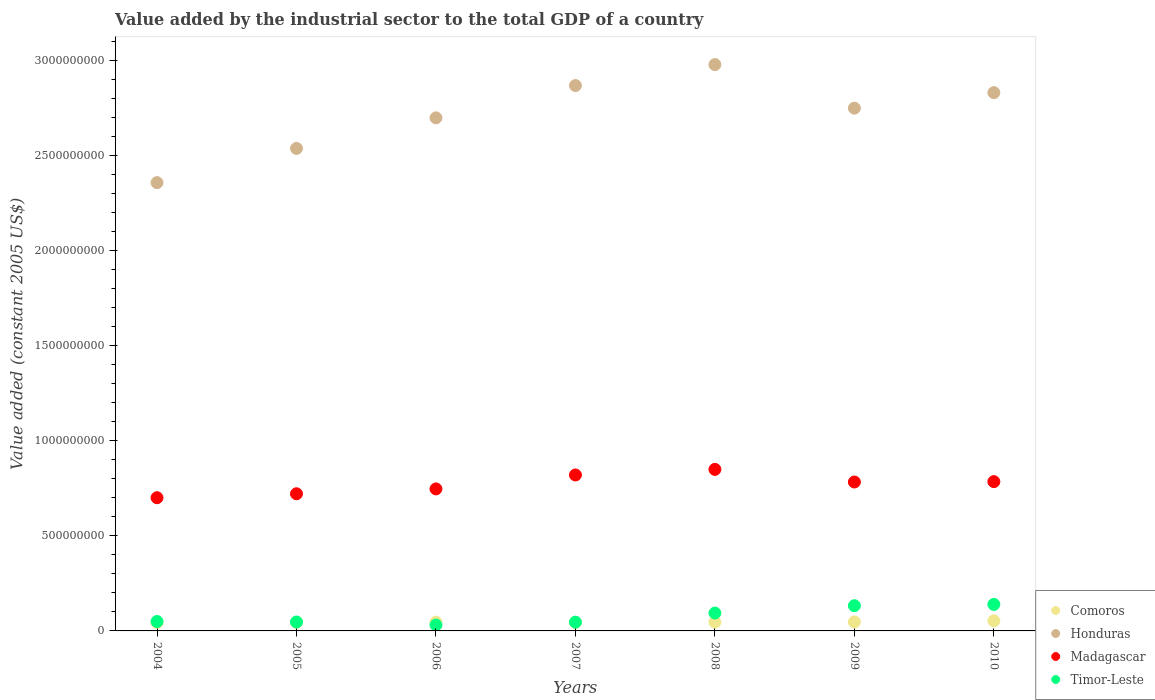What is the value added by the industrial sector in Honduras in 2009?
Provide a succinct answer. 2.75e+09. Across all years, what is the maximum value added by the industrial sector in Timor-Leste?
Ensure brevity in your answer.  1.39e+08. Across all years, what is the minimum value added by the industrial sector in Comoros?
Offer a terse response. 4.38e+07. In which year was the value added by the industrial sector in Madagascar maximum?
Make the answer very short. 2008. In which year was the value added by the industrial sector in Honduras minimum?
Offer a terse response. 2004. What is the total value added by the industrial sector in Timor-Leste in the graph?
Give a very brief answer. 5.40e+08. What is the difference between the value added by the industrial sector in Madagascar in 2005 and that in 2009?
Make the answer very short. -6.19e+07. What is the difference between the value added by the industrial sector in Comoros in 2005 and the value added by the industrial sector in Timor-Leste in 2009?
Provide a short and direct response. -8.77e+07. What is the average value added by the industrial sector in Comoros per year?
Offer a terse response. 4.65e+07. In the year 2006, what is the difference between the value added by the industrial sector in Comoros and value added by the industrial sector in Honduras?
Keep it short and to the point. -2.65e+09. In how many years, is the value added by the industrial sector in Honduras greater than 1600000000 US$?
Your answer should be very brief. 7. What is the ratio of the value added by the industrial sector in Honduras in 2004 to that in 2007?
Your answer should be compact. 0.82. Is the difference between the value added by the industrial sector in Comoros in 2005 and 2010 greater than the difference between the value added by the industrial sector in Honduras in 2005 and 2010?
Your answer should be very brief. Yes. What is the difference between the highest and the second highest value added by the industrial sector in Honduras?
Provide a short and direct response. 1.10e+08. What is the difference between the highest and the lowest value added by the industrial sector in Timor-Leste?
Provide a succinct answer. 1.08e+08. In how many years, is the value added by the industrial sector in Honduras greater than the average value added by the industrial sector in Honduras taken over all years?
Provide a succinct answer. 4. Is the sum of the value added by the industrial sector in Honduras in 2005 and 2006 greater than the maximum value added by the industrial sector in Madagascar across all years?
Provide a short and direct response. Yes. Is it the case that in every year, the sum of the value added by the industrial sector in Honduras and value added by the industrial sector in Comoros  is greater than the sum of value added by the industrial sector in Madagascar and value added by the industrial sector in Timor-Leste?
Your answer should be very brief. No. Does the value added by the industrial sector in Honduras monotonically increase over the years?
Keep it short and to the point. No. What is the difference between two consecutive major ticks on the Y-axis?
Offer a terse response. 5.00e+08. Are the values on the major ticks of Y-axis written in scientific E-notation?
Offer a very short reply. No. Does the graph contain any zero values?
Make the answer very short. No. What is the title of the graph?
Make the answer very short. Value added by the industrial sector to the total GDP of a country. Does "France" appear as one of the legend labels in the graph?
Your response must be concise. No. What is the label or title of the X-axis?
Your answer should be compact. Years. What is the label or title of the Y-axis?
Your response must be concise. Value added (constant 2005 US$). What is the Value added (constant 2005 US$) of Comoros in 2004?
Make the answer very short. 4.38e+07. What is the Value added (constant 2005 US$) of Honduras in 2004?
Your answer should be compact. 2.36e+09. What is the Value added (constant 2005 US$) in Madagascar in 2004?
Ensure brevity in your answer.  7.01e+08. What is the Value added (constant 2005 US$) of Timor-Leste in 2004?
Your answer should be very brief. 4.95e+07. What is the Value added (constant 2005 US$) of Comoros in 2005?
Give a very brief answer. 4.49e+07. What is the Value added (constant 2005 US$) of Honduras in 2005?
Provide a short and direct response. 2.54e+09. What is the Value added (constant 2005 US$) of Madagascar in 2005?
Your answer should be compact. 7.21e+08. What is the Value added (constant 2005 US$) of Timor-Leste in 2005?
Keep it short and to the point. 4.70e+07. What is the Value added (constant 2005 US$) of Comoros in 2006?
Provide a succinct answer. 4.63e+07. What is the Value added (constant 2005 US$) of Honduras in 2006?
Your response must be concise. 2.70e+09. What is the Value added (constant 2005 US$) in Madagascar in 2006?
Ensure brevity in your answer.  7.47e+08. What is the Value added (constant 2005 US$) in Timor-Leste in 2006?
Your response must be concise. 3.11e+07. What is the Value added (constant 2005 US$) in Comoros in 2007?
Provide a succinct answer. 4.42e+07. What is the Value added (constant 2005 US$) in Honduras in 2007?
Offer a very short reply. 2.87e+09. What is the Value added (constant 2005 US$) of Madagascar in 2007?
Your answer should be compact. 8.20e+08. What is the Value added (constant 2005 US$) of Timor-Leste in 2007?
Provide a succinct answer. 4.62e+07. What is the Value added (constant 2005 US$) in Comoros in 2008?
Provide a short and direct response. 4.62e+07. What is the Value added (constant 2005 US$) in Honduras in 2008?
Your answer should be very brief. 2.98e+09. What is the Value added (constant 2005 US$) in Madagascar in 2008?
Your response must be concise. 8.50e+08. What is the Value added (constant 2005 US$) in Timor-Leste in 2008?
Your answer should be very brief. 9.40e+07. What is the Value added (constant 2005 US$) in Comoros in 2009?
Give a very brief answer. 4.71e+07. What is the Value added (constant 2005 US$) of Honduras in 2009?
Offer a terse response. 2.75e+09. What is the Value added (constant 2005 US$) of Madagascar in 2009?
Your response must be concise. 7.83e+08. What is the Value added (constant 2005 US$) of Timor-Leste in 2009?
Provide a succinct answer. 1.33e+08. What is the Value added (constant 2005 US$) in Comoros in 2010?
Provide a short and direct response. 5.31e+07. What is the Value added (constant 2005 US$) in Honduras in 2010?
Offer a very short reply. 2.83e+09. What is the Value added (constant 2005 US$) in Madagascar in 2010?
Provide a short and direct response. 7.85e+08. What is the Value added (constant 2005 US$) in Timor-Leste in 2010?
Offer a terse response. 1.39e+08. Across all years, what is the maximum Value added (constant 2005 US$) of Comoros?
Ensure brevity in your answer.  5.31e+07. Across all years, what is the maximum Value added (constant 2005 US$) in Honduras?
Provide a short and direct response. 2.98e+09. Across all years, what is the maximum Value added (constant 2005 US$) of Madagascar?
Make the answer very short. 8.50e+08. Across all years, what is the maximum Value added (constant 2005 US$) in Timor-Leste?
Your response must be concise. 1.39e+08. Across all years, what is the minimum Value added (constant 2005 US$) in Comoros?
Ensure brevity in your answer.  4.38e+07. Across all years, what is the minimum Value added (constant 2005 US$) of Honduras?
Offer a terse response. 2.36e+09. Across all years, what is the minimum Value added (constant 2005 US$) in Madagascar?
Make the answer very short. 7.01e+08. Across all years, what is the minimum Value added (constant 2005 US$) in Timor-Leste?
Make the answer very short. 3.11e+07. What is the total Value added (constant 2005 US$) in Comoros in the graph?
Make the answer very short. 3.26e+08. What is the total Value added (constant 2005 US$) in Honduras in the graph?
Ensure brevity in your answer.  1.90e+1. What is the total Value added (constant 2005 US$) in Madagascar in the graph?
Your answer should be compact. 5.41e+09. What is the total Value added (constant 2005 US$) of Timor-Leste in the graph?
Your answer should be very brief. 5.40e+08. What is the difference between the Value added (constant 2005 US$) of Comoros in 2004 and that in 2005?
Keep it short and to the point. -1.10e+06. What is the difference between the Value added (constant 2005 US$) in Honduras in 2004 and that in 2005?
Your answer should be very brief. -1.80e+08. What is the difference between the Value added (constant 2005 US$) of Madagascar in 2004 and that in 2005?
Keep it short and to the point. -2.08e+07. What is the difference between the Value added (constant 2005 US$) in Timor-Leste in 2004 and that in 2005?
Provide a short and direct response. 2.52e+06. What is the difference between the Value added (constant 2005 US$) of Comoros in 2004 and that in 2006?
Your response must be concise. -2.42e+06. What is the difference between the Value added (constant 2005 US$) in Honduras in 2004 and that in 2006?
Keep it short and to the point. -3.41e+08. What is the difference between the Value added (constant 2005 US$) in Madagascar in 2004 and that in 2006?
Your response must be concise. -4.63e+07. What is the difference between the Value added (constant 2005 US$) in Timor-Leste in 2004 and that in 2006?
Your answer should be very brief. 1.85e+07. What is the difference between the Value added (constant 2005 US$) in Comoros in 2004 and that in 2007?
Offer a very short reply. -4.05e+05. What is the difference between the Value added (constant 2005 US$) in Honduras in 2004 and that in 2007?
Your answer should be very brief. -5.11e+08. What is the difference between the Value added (constant 2005 US$) in Madagascar in 2004 and that in 2007?
Your answer should be very brief. -1.20e+08. What is the difference between the Value added (constant 2005 US$) of Timor-Leste in 2004 and that in 2007?
Give a very brief answer. 3.36e+06. What is the difference between the Value added (constant 2005 US$) in Comoros in 2004 and that in 2008?
Your response must be concise. -2.34e+06. What is the difference between the Value added (constant 2005 US$) in Honduras in 2004 and that in 2008?
Your answer should be very brief. -6.21e+08. What is the difference between the Value added (constant 2005 US$) in Madagascar in 2004 and that in 2008?
Ensure brevity in your answer.  -1.49e+08. What is the difference between the Value added (constant 2005 US$) in Timor-Leste in 2004 and that in 2008?
Give a very brief answer. -4.45e+07. What is the difference between the Value added (constant 2005 US$) of Comoros in 2004 and that in 2009?
Your answer should be very brief. -3.30e+06. What is the difference between the Value added (constant 2005 US$) in Honduras in 2004 and that in 2009?
Provide a succinct answer. -3.92e+08. What is the difference between the Value added (constant 2005 US$) in Madagascar in 2004 and that in 2009?
Your response must be concise. -8.26e+07. What is the difference between the Value added (constant 2005 US$) in Timor-Leste in 2004 and that in 2009?
Your answer should be very brief. -8.31e+07. What is the difference between the Value added (constant 2005 US$) of Comoros in 2004 and that in 2010?
Offer a terse response. -9.29e+06. What is the difference between the Value added (constant 2005 US$) in Honduras in 2004 and that in 2010?
Provide a succinct answer. -4.73e+08. What is the difference between the Value added (constant 2005 US$) of Madagascar in 2004 and that in 2010?
Make the answer very short. -8.46e+07. What is the difference between the Value added (constant 2005 US$) of Timor-Leste in 2004 and that in 2010?
Your response must be concise. -8.98e+07. What is the difference between the Value added (constant 2005 US$) in Comoros in 2005 and that in 2006?
Ensure brevity in your answer.  -1.32e+06. What is the difference between the Value added (constant 2005 US$) in Honduras in 2005 and that in 2006?
Offer a very short reply. -1.61e+08. What is the difference between the Value added (constant 2005 US$) of Madagascar in 2005 and that in 2006?
Give a very brief answer. -2.55e+07. What is the difference between the Value added (constant 2005 US$) of Timor-Leste in 2005 and that in 2006?
Give a very brief answer. 1.59e+07. What is the difference between the Value added (constant 2005 US$) of Comoros in 2005 and that in 2007?
Keep it short and to the point. 6.92e+05. What is the difference between the Value added (constant 2005 US$) of Honduras in 2005 and that in 2007?
Your answer should be very brief. -3.31e+08. What is the difference between the Value added (constant 2005 US$) of Madagascar in 2005 and that in 2007?
Keep it short and to the point. -9.88e+07. What is the difference between the Value added (constant 2005 US$) in Timor-Leste in 2005 and that in 2007?
Ensure brevity in your answer.  8.39e+05. What is the difference between the Value added (constant 2005 US$) in Comoros in 2005 and that in 2008?
Provide a succinct answer. -1.24e+06. What is the difference between the Value added (constant 2005 US$) of Honduras in 2005 and that in 2008?
Your response must be concise. -4.41e+08. What is the difference between the Value added (constant 2005 US$) in Madagascar in 2005 and that in 2008?
Provide a short and direct response. -1.28e+08. What is the difference between the Value added (constant 2005 US$) of Timor-Leste in 2005 and that in 2008?
Keep it short and to the point. -4.70e+07. What is the difference between the Value added (constant 2005 US$) of Comoros in 2005 and that in 2009?
Offer a terse response. -2.20e+06. What is the difference between the Value added (constant 2005 US$) of Honduras in 2005 and that in 2009?
Your answer should be very brief. -2.12e+08. What is the difference between the Value added (constant 2005 US$) of Madagascar in 2005 and that in 2009?
Give a very brief answer. -6.19e+07. What is the difference between the Value added (constant 2005 US$) of Timor-Leste in 2005 and that in 2009?
Offer a very short reply. -8.56e+07. What is the difference between the Value added (constant 2005 US$) in Comoros in 2005 and that in 2010?
Offer a very short reply. -8.19e+06. What is the difference between the Value added (constant 2005 US$) in Honduras in 2005 and that in 2010?
Your answer should be very brief. -2.93e+08. What is the difference between the Value added (constant 2005 US$) in Madagascar in 2005 and that in 2010?
Your response must be concise. -6.38e+07. What is the difference between the Value added (constant 2005 US$) in Timor-Leste in 2005 and that in 2010?
Your answer should be compact. -9.23e+07. What is the difference between the Value added (constant 2005 US$) in Comoros in 2006 and that in 2007?
Your answer should be very brief. 2.01e+06. What is the difference between the Value added (constant 2005 US$) in Honduras in 2006 and that in 2007?
Offer a very short reply. -1.70e+08. What is the difference between the Value added (constant 2005 US$) in Madagascar in 2006 and that in 2007?
Your response must be concise. -7.33e+07. What is the difference between the Value added (constant 2005 US$) of Timor-Leste in 2006 and that in 2007?
Give a very brief answer. -1.51e+07. What is the difference between the Value added (constant 2005 US$) of Comoros in 2006 and that in 2008?
Keep it short and to the point. 7.71e+04. What is the difference between the Value added (constant 2005 US$) of Honduras in 2006 and that in 2008?
Your answer should be very brief. -2.80e+08. What is the difference between the Value added (constant 2005 US$) of Madagascar in 2006 and that in 2008?
Ensure brevity in your answer.  -1.03e+08. What is the difference between the Value added (constant 2005 US$) in Timor-Leste in 2006 and that in 2008?
Your response must be concise. -6.29e+07. What is the difference between the Value added (constant 2005 US$) in Comoros in 2006 and that in 2009?
Your response must be concise. -8.80e+05. What is the difference between the Value added (constant 2005 US$) in Honduras in 2006 and that in 2009?
Your answer should be very brief. -5.09e+07. What is the difference between the Value added (constant 2005 US$) of Madagascar in 2006 and that in 2009?
Ensure brevity in your answer.  -3.64e+07. What is the difference between the Value added (constant 2005 US$) in Timor-Leste in 2006 and that in 2009?
Offer a very short reply. -1.02e+08. What is the difference between the Value added (constant 2005 US$) of Comoros in 2006 and that in 2010?
Provide a succinct answer. -6.87e+06. What is the difference between the Value added (constant 2005 US$) in Honduras in 2006 and that in 2010?
Your answer should be very brief. -1.33e+08. What is the difference between the Value added (constant 2005 US$) of Madagascar in 2006 and that in 2010?
Make the answer very short. -3.83e+07. What is the difference between the Value added (constant 2005 US$) of Timor-Leste in 2006 and that in 2010?
Keep it short and to the point. -1.08e+08. What is the difference between the Value added (constant 2005 US$) of Comoros in 2007 and that in 2008?
Your answer should be compact. -1.94e+06. What is the difference between the Value added (constant 2005 US$) in Honduras in 2007 and that in 2008?
Provide a short and direct response. -1.10e+08. What is the difference between the Value added (constant 2005 US$) in Madagascar in 2007 and that in 2008?
Offer a very short reply. -2.93e+07. What is the difference between the Value added (constant 2005 US$) in Timor-Leste in 2007 and that in 2008?
Your answer should be very brief. -4.78e+07. What is the difference between the Value added (constant 2005 US$) in Comoros in 2007 and that in 2009?
Your answer should be very brief. -2.89e+06. What is the difference between the Value added (constant 2005 US$) of Honduras in 2007 and that in 2009?
Keep it short and to the point. 1.19e+08. What is the difference between the Value added (constant 2005 US$) of Madagascar in 2007 and that in 2009?
Your answer should be very brief. 3.70e+07. What is the difference between the Value added (constant 2005 US$) in Timor-Leste in 2007 and that in 2009?
Your answer should be very brief. -8.64e+07. What is the difference between the Value added (constant 2005 US$) in Comoros in 2007 and that in 2010?
Give a very brief answer. -8.88e+06. What is the difference between the Value added (constant 2005 US$) of Honduras in 2007 and that in 2010?
Ensure brevity in your answer.  3.72e+07. What is the difference between the Value added (constant 2005 US$) in Madagascar in 2007 and that in 2010?
Your response must be concise. 3.50e+07. What is the difference between the Value added (constant 2005 US$) of Timor-Leste in 2007 and that in 2010?
Make the answer very short. -9.32e+07. What is the difference between the Value added (constant 2005 US$) in Comoros in 2008 and that in 2009?
Your answer should be compact. -9.57e+05. What is the difference between the Value added (constant 2005 US$) of Honduras in 2008 and that in 2009?
Your answer should be very brief. 2.29e+08. What is the difference between the Value added (constant 2005 US$) of Madagascar in 2008 and that in 2009?
Offer a very short reply. 6.63e+07. What is the difference between the Value added (constant 2005 US$) in Timor-Leste in 2008 and that in 2009?
Your response must be concise. -3.86e+07. What is the difference between the Value added (constant 2005 US$) of Comoros in 2008 and that in 2010?
Give a very brief answer. -6.95e+06. What is the difference between the Value added (constant 2005 US$) of Honduras in 2008 and that in 2010?
Provide a succinct answer. 1.47e+08. What is the difference between the Value added (constant 2005 US$) of Madagascar in 2008 and that in 2010?
Ensure brevity in your answer.  6.43e+07. What is the difference between the Value added (constant 2005 US$) in Timor-Leste in 2008 and that in 2010?
Your answer should be very brief. -4.53e+07. What is the difference between the Value added (constant 2005 US$) of Comoros in 2009 and that in 2010?
Keep it short and to the point. -5.99e+06. What is the difference between the Value added (constant 2005 US$) in Honduras in 2009 and that in 2010?
Provide a short and direct response. -8.17e+07. What is the difference between the Value added (constant 2005 US$) of Madagascar in 2009 and that in 2010?
Provide a short and direct response. -1.94e+06. What is the difference between the Value added (constant 2005 US$) of Timor-Leste in 2009 and that in 2010?
Give a very brief answer. -6.71e+06. What is the difference between the Value added (constant 2005 US$) in Comoros in 2004 and the Value added (constant 2005 US$) in Honduras in 2005?
Make the answer very short. -2.49e+09. What is the difference between the Value added (constant 2005 US$) of Comoros in 2004 and the Value added (constant 2005 US$) of Madagascar in 2005?
Your answer should be very brief. -6.78e+08. What is the difference between the Value added (constant 2005 US$) in Comoros in 2004 and the Value added (constant 2005 US$) in Timor-Leste in 2005?
Offer a very short reply. -3.16e+06. What is the difference between the Value added (constant 2005 US$) in Honduras in 2004 and the Value added (constant 2005 US$) in Madagascar in 2005?
Offer a terse response. 1.64e+09. What is the difference between the Value added (constant 2005 US$) of Honduras in 2004 and the Value added (constant 2005 US$) of Timor-Leste in 2005?
Provide a succinct answer. 2.31e+09. What is the difference between the Value added (constant 2005 US$) in Madagascar in 2004 and the Value added (constant 2005 US$) in Timor-Leste in 2005?
Provide a succinct answer. 6.54e+08. What is the difference between the Value added (constant 2005 US$) in Comoros in 2004 and the Value added (constant 2005 US$) in Honduras in 2006?
Your answer should be very brief. -2.65e+09. What is the difference between the Value added (constant 2005 US$) of Comoros in 2004 and the Value added (constant 2005 US$) of Madagascar in 2006?
Offer a very short reply. -7.03e+08. What is the difference between the Value added (constant 2005 US$) in Comoros in 2004 and the Value added (constant 2005 US$) in Timor-Leste in 2006?
Give a very brief answer. 1.28e+07. What is the difference between the Value added (constant 2005 US$) of Honduras in 2004 and the Value added (constant 2005 US$) of Madagascar in 2006?
Keep it short and to the point. 1.61e+09. What is the difference between the Value added (constant 2005 US$) of Honduras in 2004 and the Value added (constant 2005 US$) of Timor-Leste in 2006?
Your answer should be compact. 2.33e+09. What is the difference between the Value added (constant 2005 US$) of Madagascar in 2004 and the Value added (constant 2005 US$) of Timor-Leste in 2006?
Make the answer very short. 6.70e+08. What is the difference between the Value added (constant 2005 US$) in Comoros in 2004 and the Value added (constant 2005 US$) in Honduras in 2007?
Offer a terse response. -2.82e+09. What is the difference between the Value added (constant 2005 US$) in Comoros in 2004 and the Value added (constant 2005 US$) in Madagascar in 2007?
Provide a short and direct response. -7.76e+08. What is the difference between the Value added (constant 2005 US$) of Comoros in 2004 and the Value added (constant 2005 US$) of Timor-Leste in 2007?
Offer a very short reply. -2.32e+06. What is the difference between the Value added (constant 2005 US$) in Honduras in 2004 and the Value added (constant 2005 US$) in Madagascar in 2007?
Your answer should be compact. 1.54e+09. What is the difference between the Value added (constant 2005 US$) in Honduras in 2004 and the Value added (constant 2005 US$) in Timor-Leste in 2007?
Your answer should be very brief. 2.31e+09. What is the difference between the Value added (constant 2005 US$) in Madagascar in 2004 and the Value added (constant 2005 US$) in Timor-Leste in 2007?
Offer a terse response. 6.55e+08. What is the difference between the Value added (constant 2005 US$) in Comoros in 2004 and the Value added (constant 2005 US$) in Honduras in 2008?
Make the answer very short. -2.93e+09. What is the difference between the Value added (constant 2005 US$) in Comoros in 2004 and the Value added (constant 2005 US$) in Madagascar in 2008?
Offer a very short reply. -8.06e+08. What is the difference between the Value added (constant 2005 US$) of Comoros in 2004 and the Value added (constant 2005 US$) of Timor-Leste in 2008?
Your answer should be very brief. -5.02e+07. What is the difference between the Value added (constant 2005 US$) in Honduras in 2004 and the Value added (constant 2005 US$) in Madagascar in 2008?
Your answer should be compact. 1.51e+09. What is the difference between the Value added (constant 2005 US$) in Honduras in 2004 and the Value added (constant 2005 US$) in Timor-Leste in 2008?
Ensure brevity in your answer.  2.26e+09. What is the difference between the Value added (constant 2005 US$) in Madagascar in 2004 and the Value added (constant 2005 US$) in Timor-Leste in 2008?
Keep it short and to the point. 6.07e+08. What is the difference between the Value added (constant 2005 US$) in Comoros in 2004 and the Value added (constant 2005 US$) in Honduras in 2009?
Give a very brief answer. -2.71e+09. What is the difference between the Value added (constant 2005 US$) of Comoros in 2004 and the Value added (constant 2005 US$) of Madagascar in 2009?
Keep it short and to the point. -7.39e+08. What is the difference between the Value added (constant 2005 US$) in Comoros in 2004 and the Value added (constant 2005 US$) in Timor-Leste in 2009?
Your answer should be compact. -8.88e+07. What is the difference between the Value added (constant 2005 US$) of Honduras in 2004 and the Value added (constant 2005 US$) of Madagascar in 2009?
Keep it short and to the point. 1.57e+09. What is the difference between the Value added (constant 2005 US$) in Honduras in 2004 and the Value added (constant 2005 US$) in Timor-Leste in 2009?
Give a very brief answer. 2.23e+09. What is the difference between the Value added (constant 2005 US$) in Madagascar in 2004 and the Value added (constant 2005 US$) in Timor-Leste in 2009?
Offer a very short reply. 5.68e+08. What is the difference between the Value added (constant 2005 US$) in Comoros in 2004 and the Value added (constant 2005 US$) in Honduras in 2010?
Ensure brevity in your answer.  -2.79e+09. What is the difference between the Value added (constant 2005 US$) in Comoros in 2004 and the Value added (constant 2005 US$) in Madagascar in 2010?
Give a very brief answer. -7.41e+08. What is the difference between the Value added (constant 2005 US$) in Comoros in 2004 and the Value added (constant 2005 US$) in Timor-Leste in 2010?
Offer a very short reply. -9.55e+07. What is the difference between the Value added (constant 2005 US$) of Honduras in 2004 and the Value added (constant 2005 US$) of Madagascar in 2010?
Your answer should be very brief. 1.57e+09. What is the difference between the Value added (constant 2005 US$) in Honduras in 2004 and the Value added (constant 2005 US$) in Timor-Leste in 2010?
Ensure brevity in your answer.  2.22e+09. What is the difference between the Value added (constant 2005 US$) in Madagascar in 2004 and the Value added (constant 2005 US$) in Timor-Leste in 2010?
Provide a succinct answer. 5.61e+08. What is the difference between the Value added (constant 2005 US$) of Comoros in 2005 and the Value added (constant 2005 US$) of Honduras in 2006?
Your response must be concise. -2.65e+09. What is the difference between the Value added (constant 2005 US$) in Comoros in 2005 and the Value added (constant 2005 US$) in Madagascar in 2006?
Make the answer very short. -7.02e+08. What is the difference between the Value added (constant 2005 US$) of Comoros in 2005 and the Value added (constant 2005 US$) of Timor-Leste in 2006?
Provide a short and direct response. 1.39e+07. What is the difference between the Value added (constant 2005 US$) in Honduras in 2005 and the Value added (constant 2005 US$) in Madagascar in 2006?
Your answer should be compact. 1.79e+09. What is the difference between the Value added (constant 2005 US$) of Honduras in 2005 and the Value added (constant 2005 US$) of Timor-Leste in 2006?
Give a very brief answer. 2.51e+09. What is the difference between the Value added (constant 2005 US$) in Madagascar in 2005 and the Value added (constant 2005 US$) in Timor-Leste in 2006?
Offer a very short reply. 6.90e+08. What is the difference between the Value added (constant 2005 US$) in Comoros in 2005 and the Value added (constant 2005 US$) in Honduras in 2007?
Your response must be concise. -2.82e+09. What is the difference between the Value added (constant 2005 US$) of Comoros in 2005 and the Value added (constant 2005 US$) of Madagascar in 2007?
Ensure brevity in your answer.  -7.75e+08. What is the difference between the Value added (constant 2005 US$) of Comoros in 2005 and the Value added (constant 2005 US$) of Timor-Leste in 2007?
Offer a terse response. -1.23e+06. What is the difference between the Value added (constant 2005 US$) in Honduras in 2005 and the Value added (constant 2005 US$) in Madagascar in 2007?
Offer a very short reply. 1.72e+09. What is the difference between the Value added (constant 2005 US$) of Honduras in 2005 and the Value added (constant 2005 US$) of Timor-Leste in 2007?
Ensure brevity in your answer.  2.49e+09. What is the difference between the Value added (constant 2005 US$) of Madagascar in 2005 and the Value added (constant 2005 US$) of Timor-Leste in 2007?
Keep it short and to the point. 6.75e+08. What is the difference between the Value added (constant 2005 US$) of Comoros in 2005 and the Value added (constant 2005 US$) of Honduras in 2008?
Keep it short and to the point. -2.93e+09. What is the difference between the Value added (constant 2005 US$) in Comoros in 2005 and the Value added (constant 2005 US$) in Madagascar in 2008?
Your answer should be very brief. -8.05e+08. What is the difference between the Value added (constant 2005 US$) in Comoros in 2005 and the Value added (constant 2005 US$) in Timor-Leste in 2008?
Give a very brief answer. -4.91e+07. What is the difference between the Value added (constant 2005 US$) of Honduras in 2005 and the Value added (constant 2005 US$) of Madagascar in 2008?
Make the answer very short. 1.69e+09. What is the difference between the Value added (constant 2005 US$) in Honduras in 2005 and the Value added (constant 2005 US$) in Timor-Leste in 2008?
Keep it short and to the point. 2.44e+09. What is the difference between the Value added (constant 2005 US$) in Madagascar in 2005 and the Value added (constant 2005 US$) in Timor-Leste in 2008?
Keep it short and to the point. 6.27e+08. What is the difference between the Value added (constant 2005 US$) of Comoros in 2005 and the Value added (constant 2005 US$) of Honduras in 2009?
Offer a very short reply. -2.70e+09. What is the difference between the Value added (constant 2005 US$) of Comoros in 2005 and the Value added (constant 2005 US$) of Madagascar in 2009?
Your answer should be compact. -7.38e+08. What is the difference between the Value added (constant 2005 US$) in Comoros in 2005 and the Value added (constant 2005 US$) in Timor-Leste in 2009?
Your answer should be very brief. -8.77e+07. What is the difference between the Value added (constant 2005 US$) of Honduras in 2005 and the Value added (constant 2005 US$) of Madagascar in 2009?
Offer a terse response. 1.75e+09. What is the difference between the Value added (constant 2005 US$) in Honduras in 2005 and the Value added (constant 2005 US$) in Timor-Leste in 2009?
Ensure brevity in your answer.  2.41e+09. What is the difference between the Value added (constant 2005 US$) in Madagascar in 2005 and the Value added (constant 2005 US$) in Timor-Leste in 2009?
Make the answer very short. 5.89e+08. What is the difference between the Value added (constant 2005 US$) in Comoros in 2005 and the Value added (constant 2005 US$) in Honduras in 2010?
Offer a terse response. -2.79e+09. What is the difference between the Value added (constant 2005 US$) of Comoros in 2005 and the Value added (constant 2005 US$) of Madagascar in 2010?
Your answer should be very brief. -7.40e+08. What is the difference between the Value added (constant 2005 US$) in Comoros in 2005 and the Value added (constant 2005 US$) in Timor-Leste in 2010?
Make the answer very short. -9.44e+07. What is the difference between the Value added (constant 2005 US$) of Honduras in 2005 and the Value added (constant 2005 US$) of Madagascar in 2010?
Your answer should be very brief. 1.75e+09. What is the difference between the Value added (constant 2005 US$) of Honduras in 2005 and the Value added (constant 2005 US$) of Timor-Leste in 2010?
Make the answer very short. 2.40e+09. What is the difference between the Value added (constant 2005 US$) of Madagascar in 2005 and the Value added (constant 2005 US$) of Timor-Leste in 2010?
Offer a terse response. 5.82e+08. What is the difference between the Value added (constant 2005 US$) of Comoros in 2006 and the Value added (constant 2005 US$) of Honduras in 2007?
Your response must be concise. -2.82e+09. What is the difference between the Value added (constant 2005 US$) in Comoros in 2006 and the Value added (constant 2005 US$) in Madagascar in 2007?
Offer a terse response. -7.74e+08. What is the difference between the Value added (constant 2005 US$) in Comoros in 2006 and the Value added (constant 2005 US$) in Timor-Leste in 2007?
Provide a succinct answer. 9.45e+04. What is the difference between the Value added (constant 2005 US$) in Honduras in 2006 and the Value added (constant 2005 US$) in Madagascar in 2007?
Provide a succinct answer. 1.88e+09. What is the difference between the Value added (constant 2005 US$) in Honduras in 2006 and the Value added (constant 2005 US$) in Timor-Leste in 2007?
Your response must be concise. 2.65e+09. What is the difference between the Value added (constant 2005 US$) of Madagascar in 2006 and the Value added (constant 2005 US$) of Timor-Leste in 2007?
Make the answer very short. 7.01e+08. What is the difference between the Value added (constant 2005 US$) of Comoros in 2006 and the Value added (constant 2005 US$) of Honduras in 2008?
Offer a very short reply. -2.93e+09. What is the difference between the Value added (constant 2005 US$) of Comoros in 2006 and the Value added (constant 2005 US$) of Madagascar in 2008?
Provide a short and direct response. -8.03e+08. What is the difference between the Value added (constant 2005 US$) of Comoros in 2006 and the Value added (constant 2005 US$) of Timor-Leste in 2008?
Make the answer very short. -4.77e+07. What is the difference between the Value added (constant 2005 US$) of Honduras in 2006 and the Value added (constant 2005 US$) of Madagascar in 2008?
Your answer should be very brief. 1.85e+09. What is the difference between the Value added (constant 2005 US$) of Honduras in 2006 and the Value added (constant 2005 US$) of Timor-Leste in 2008?
Make the answer very short. 2.60e+09. What is the difference between the Value added (constant 2005 US$) of Madagascar in 2006 and the Value added (constant 2005 US$) of Timor-Leste in 2008?
Make the answer very short. 6.53e+08. What is the difference between the Value added (constant 2005 US$) in Comoros in 2006 and the Value added (constant 2005 US$) in Honduras in 2009?
Ensure brevity in your answer.  -2.70e+09. What is the difference between the Value added (constant 2005 US$) of Comoros in 2006 and the Value added (constant 2005 US$) of Madagascar in 2009?
Your answer should be very brief. -7.37e+08. What is the difference between the Value added (constant 2005 US$) in Comoros in 2006 and the Value added (constant 2005 US$) in Timor-Leste in 2009?
Give a very brief answer. -8.64e+07. What is the difference between the Value added (constant 2005 US$) in Honduras in 2006 and the Value added (constant 2005 US$) in Madagascar in 2009?
Provide a short and direct response. 1.92e+09. What is the difference between the Value added (constant 2005 US$) of Honduras in 2006 and the Value added (constant 2005 US$) of Timor-Leste in 2009?
Ensure brevity in your answer.  2.57e+09. What is the difference between the Value added (constant 2005 US$) in Madagascar in 2006 and the Value added (constant 2005 US$) in Timor-Leste in 2009?
Your response must be concise. 6.14e+08. What is the difference between the Value added (constant 2005 US$) in Comoros in 2006 and the Value added (constant 2005 US$) in Honduras in 2010?
Offer a terse response. -2.79e+09. What is the difference between the Value added (constant 2005 US$) of Comoros in 2006 and the Value added (constant 2005 US$) of Madagascar in 2010?
Your answer should be compact. -7.39e+08. What is the difference between the Value added (constant 2005 US$) of Comoros in 2006 and the Value added (constant 2005 US$) of Timor-Leste in 2010?
Offer a very short reply. -9.31e+07. What is the difference between the Value added (constant 2005 US$) of Honduras in 2006 and the Value added (constant 2005 US$) of Madagascar in 2010?
Provide a succinct answer. 1.91e+09. What is the difference between the Value added (constant 2005 US$) in Honduras in 2006 and the Value added (constant 2005 US$) in Timor-Leste in 2010?
Your response must be concise. 2.56e+09. What is the difference between the Value added (constant 2005 US$) of Madagascar in 2006 and the Value added (constant 2005 US$) of Timor-Leste in 2010?
Offer a very short reply. 6.08e+08. What is the difference between the Value added (constant 2005 US$) in Comoros in 2007 and the Value added (constant 2005 US$) in Honduras in 2008?
Provide a short and direct response. -2.93e+09. What is the difference between the Value added (constant 2005 US$) in Comoros in 2007 and the Value added (constant 2005 US$) in Madagascar in 2008?
Provide a succinct answer. -8.05e+08. What is the difference between the Value added (constant 2005 US$) of Comoros in 2007 and the Value added (constant 2005 US$) of Timor-Leste in 2008?
Your response must be concise. -4.98e+07. What is the difference between the Value added (constant 2005 US$) in Honduras in 2007 and the Value added (constant 2005 US$) in Madagascar in 2008?
Keep it short and to the point. 2.02e+09. What is the difference between the Value added (constant 2005 US$) in Honduras in 2007 and the Value added (constant 2005 US$) in Timor-Leste in 2008?
Your response must be concise. 2.77e+09. What is the difference between the Value added (constant 2005 US$) of Madagascar in 2007 and the Value added (constant 2005 US$) of Timor-Leste in 2008?
Give a very brief answer. 7.26e+08. What is the difference between the Value added (constant 2005 US$) of Comoros in 2007 and the Value added (constant 2005 US$) of Honduras in 2009?
Ensure brevity in your answer.  -2.71e+09. What is the difference between the Value added (constant 2005 US$) in Comoros in 2007 and the Value added (constant 2005 US$) in Madagascar in 2009?
Offer a terse response. -7.39e+08. What is the difference between the Value added (constant 2005 US$) of Comoros in 2007 and the Value added (constant 2005 US$) of Timor-Leste in 2009?
Your answer should be very brief. -8.84e+07. What is the difference between the Value added (constant 2005 US$) of Honduras in 2007 and the Value added (constant 2005 US$) of Madagascar in 2009?
Ensure brevity in your answer.  2.09e+09. What is the difference between the Value added (constant 2005 US$) in Honduras in 2007 and the Value added (constant 2005 US$) in Timor-Leste in 2009?
Provide a succinct answer. 2.74e+09. What is the difference between the Value added (constant 2005 US$) in Madagascar in 2007 and the Value added (constant 2005 US$) in Timor-Leste in 2009?
Your answer should be compact. 6.88e+08. What is the difference between the Value added (constant 2005 US$) of Comoros in 2007 and the Value added (constant 2005 US$) of Honduras in 2010?
Offer a very short reply. -2.79e+09. What is the difference between the Value added (constant 2005 US$) in Comoros in 2007 and the Value added (constant 2005 US$) in Madagascar in 2010?
Make the answer very short. -7.41e+08. What is the difference between the Value added (constant 2005 US$) of Comoros in 2007 and the Value added (constant 2005 US$) of Timor-Leste in 2010?
Your answer should be compact. -9.51e+07. What is the difference between the Value added (constant 2005 US$) of Honduras in 2007 and the Value added (constant 2005 US$) of Madagascar in 2010?
Make the answer very short. 2.08e+09. What is the difference between the Value added (constant 2005 US$) of Honduras in 2007 and the Value added (constant 2005 US$) of Timor-Leste in 2010?
Provide a succinct answer. 2.73e+09. What is the difference between the Value added (constant 2005 US$) of Madagascar in 2007 and the Value added (constant 2005 US$) of Timor-Leste in 2010?
Ensure brevity in your answer.  6.81e+08. What is the difference between the Value added (constant 2005 US$) in Comoros in 2008 and the Value added (constant 2005 US$) in Honduras in 2009?
Make the answer very short. -2.70e+09. What is the difference between the Value added (constant 2005 US$) of Comoros in 2008 and the Value added (constant 2005 US$) of Madagascar in 2009?
Your response must be concise. -7.37e+08. What is the difference between the Value added (constant 2005 US$) of Comoros in 2008 and the Value added (constant 2005 US$) of Timor-Leste in 2009?
Ensure brevity in your answer.  -8.64e+07. What is the difference between the Value added (constant 2005 US$) of Honduras in 2008 and the Value added (constant 2005 US$) of Madagascar in 2009?
Your answer should be very brief. 2.20e+09. What is the difference between the Value added (constant 2005 US$) in Honduras in 2008 and the Value added (constant 2005 US$) in Timor-Leste in 2009?
Offer a very short reply. 2.85e+09. What is the difference between the Value added (constant 2005 US$) in Madagascar in 2008 and the Value added (constant 2005 US$) in Timor-Leste in 2009?
Your response must be concise. 7.17e+08. What is the difference between the Value added (constant 2005 US$) in Comoros in 2008 and the Value added (constant 2005 US$) in Honduras in 2010?
Keep it short and to the point. -2.79e+09. What is the difference between the Value added (constant 2005 US$) of Comoros in 2008 and the Value added (constant 2005 US$) of Madagascar in 2010?
Ensure brevity in your answer.  -7.39e+08. What is the difference between the Value added (constant 2005 US$) of Comoros in 2008 and the Value added (constant 2005 US$) of Timor-Leste in 2010?
Make the answer very short. -9.31e+07. What is the difference between the Value added (constant 2005 US$) in Honduras in 2008 and the Value added (constant 2005 US$) in Madagascar in 2010?
Give a very brief answer. 2.19e+09. What is the difference between the Value added (constant 2005 US$) of Honduras in 2008 and the Value added (constant 2005 US$) of Timor-Leste in 2010?
Your answer should be compact. 2.84e+09. What is the difference between the Value added (constant 2005 US$) of Madagascar in 2008 and the Value added (constant 2005 US$) of Timor-Leste in 2010?
Offer a very short reply. 7.10e+08. What is the difference between the Value added (constant 2005 US$) in Comoros in 2009 and the Value added (constant 2005 US$) in Honduras in 2010?
Your answer should be compact. -2.78e+09. What is the difference between the Value added (constant 2005 US$) in Comoros in 2009 and the Value added (constant 2005 US$) in Madagascar in 2010?
Ensure brevity in your answer.  -7.38e+08. What is the difference between the Value added (constant 2005 US$) of Comoros in 2009 and the Value added (constant 2005 US$) of Timor-Leste in 2010?
Make the answer very short. -9.22e+07. What is the difference between the Value added (constant 2005 US$) in Honduras in 2009 and the Value added (constant 2005 US$) in Madagascar in 2010?
Offer a very short reply. 1.96e+09. What is the difference between the Value added (constant 2005 US$) in Honduras in 2009 and the Value added (constant 2005 US$) in Timor-Leste in 2010?
Provide a succinct answer. 2.61e+09. What is the difference between the Value added (constant 2005 US$) in Madagascar in 2009 and the Value added (constant 2005 US$) in Timor-Leste in 2010?
Keep it short and to the point. 6.44e+08. What is the average Value added (constant 2005 US$) of Comoros per year?
Provide a short and direct response. 4.65e+07. What is the average Value added (constant 2005 US$) in Honduras per year?
Offer a terse response. 2.72e+09. What is the average Value added (constant 2005 US$) in Madagascar per year?
Give a very brief answer. 7.72e+08. What is the average Value added (constant 2005 US$) of Timor-Leste per year?
Offer a very short reply. 7.71e+07. In the year 2004, what is the difference between the Value added (constant 2005 US$) in Comoros and Value added (constant 2005 US$) in Honduras?
Give a very brief answer. -2.31e+09. In the year 2004, what is the difference between the Value added (constant 2005 US$) in Comoros and Value added (constant 2005 US$) in Madagascar?
Provide a succinct answer. -6.57e+08. In the year 2004, what is the difference between the Value added (constant 2005 US$) of Comoros and Value added (constant 2005 US$) of Timor-Leste?
Make the answer very short. -5.68e+06. In the year 2004, what is the difference between the Value added (constant 2005 US$) of Honduras and Value added (constant 2005 US$) of Madagascar?
Offer a very short reply. 1.66e+09. In the year 2004, what is the difference between the Value added (constant 2005 US$) of Honduras and Value added (constant 2005 US$) of Timor-Leste?
Offer a very short reply. 2.31e+09. In the year 2004, what is the difference between the Value added (constant 2005 US$) of Madagascar and Value added (constant 2005 US$) of Timor-Leste?
Offer a terse response. 6.51e+08. In the year 2005, what is the difference between the Value added (constant 2005 US$) of Comoros and Value added (constant 2005 US$) of Honduras?
Provide a short and direct response. -2.49e+09. In the year 2005, what is the difference between the Value added (constant 2005 US$) of Comoros and Value added (constant 2005 US$) of Madagascar?
Your answer should be very brief. -6.76e+08. In the year 2005, what is the difference between the Value added (constant 2005 US$) of Comoros and Value added (constant 2005 US$) of Timor-Leste?
Offer a terse response. -2.07e+06. In the year 2005, what is the difference between the Value added (constant 2005 US$) in Honduras and Value added (constant 2005 US$) in Madagascar?
Your answer should be very brief. 1.82e+09. In the year 2005, what is the difference between the Value added (constant 2005 US$) in Honduras and Value added (constant 2005 US$) in Timor-Leste?
Ensure brevity in your answer.  2.49e+09. In the year 2005, what is the difference between the Value added (constant 2005 US$) of Madagascar and Value added (constant 2005 US$) of Timor-Leste?
Offer a very short reply. 6.74e+08. In the year 2006, what is the difference between the Value added (constant 2005 US$) in Comoros and Value added (constant 2005 US$) in Honduras?
Offer a terse response. -2.65e+09. In the year 2006, what is the difference between the Value added (constant 2005 US$) of Comoros and Value added (constant 2005 US$) of Madagascar?
Ensure brevity in your answer.  -7.01e+08. In the year 2006, what is the difference between the Value added (constant 2005 US$) of Comoros and Value added (constant 2005 US$) of Timor-Leste?
Offer a very short reply. 1.52e+07. In the year 2006, what is the difference between the Value added (constant 2005 US$) of Honduras and Value added (constant 2005 US$) of Madagascar?
Provide a succinct answer. 1.95e+09. In the year 2006, what is the difference between the Value added (constant 2005 US$) of Honduras and Value added (constant 2005 US$) of Timor-Leste?
Your answer should be very brief. 2.67e+09. In the year 2006, what is the difference between the Value added (constant 2005 US$) in Madagascar and Value added (constant 2005 US$) in Timor-Leste?
Provide a short and direct response. 7.16e+08. In the year 2007, what is the difference between the Value added (constant 2005 US$) in Comoros and Value added (constant 2005 US$) in Honduras?
Provide a succinct answer. -2.82e+09. In the year 2007, what is the difference between the Value added (constant 2005 US$) of Comoros and Value added (constant 2005 US$) of Madagascar?
Offer a terse response. -7.76e+08. In the year 2007, what is the difference between the Value added (constant 2005 US$) of Comoros and Value added (constant 2005 US$) of Timor-Leste?
Offer a terse response. -1.92e+06. In the year 2007, what is the difference between the Value added (constant 2005 US$) of Honduras and Value added (constant 2005 US$) of Madagascar?
Keep it short and to the point. 2.05e+09. In the year 2007, what is the difference between the Value added (constant 2005 US$) in Honduras and Value added (constant 2005 US$) in Timor-Leste?
Ensure brevity in your answer.  2.82e+09. In the year 2007, what is the difference between the Value added (constant 2005 US$) of Madagascar and Value added (constant 2005 US$) of Timor-Leste?
Ensure brevity in your answer.  7.74e+08. In the year 2008, what is the difference between the Value added (constant 2005 US$) of Comoros and Value added (constant 2005 US$) of Honduras?
Ensure brevity in your answer.  -2.93e+09. In the year 2008, what is the difference between the Value added (constant 2005 US$) in Comoros and Value added (constant 2005 US$) in Madagascar?
Your response must be concise. -8.03e+08. In the year 2008, what is the difference between the Value added (constant 2005 US$) of Comoros and Value added (constant 2005 US$) of Timor-Leste?
Your answer should be very brief. -4.78e+07. In the year 2008, what is the difference between the Value added (constant 2005 US$) of Honduras and Value added (constant 2005 US$) of Madagascar?
Give a very brief answer. 2.13e+09. In the year 2008, what is the difference between the Value added (constant 2005 US$) in Honduras and Value added (constant 2005 US$) in Timor-Leste?
Give a very brief answer. 2.88e+09. In the year 2008, what is the difference between the Value added (constant 2005 US$) of Madagascar and Value added (constant 2005 US$) of Timor-Leste?
Your answer should be compact. 7.56e+08. In the year 2009, what is the difference between the Value added (constant 2005 US$) of Comoros and Value added (constant 2005 US$) of Honduras?
Provide a short and direct response. -2.70e+09. In the year 2009, what is the difference between the Value added (constant 2005 US$) in Comoros and Value added (constant 2005 US$) in Madagascar?
Give a very brief answer. -7.36e+08. In the year 2009, what is the difference between the Value added (constant 2005 US$) in Comoros and Value added (constant 2005 US$) in Timor-Leste?
Offer a very short reply. -8.55e+07. In the year 2009, what is the difference between the Value added (constant 2005 US$) of Honduras and Value added (constant 2005 US$) of Madagascar?
Your response must be concise. 1.97e+09. In the year 2009, what is the difference between the Value added (constant 2005 US$) in Honduras and Value added (constant 2005 US$) in Timor-Leste?
Your answer should be very brief. 2.62e+09. In the year 2009, what is the difference between the Value added (constant 2005 US$) of Madagascar and Value added (constant 2005 US$) of Timor-Leste?
Provide a succinct answer. 6.51e+08. In the year 2010, what is the difference between the Value added (constant 2005 US$) in Comoros and Value added (constant 2005 US$) in Honduras?
Your answer should be very brief. -2.78e+09. In the year 2010, what is the difference between the Value added (constant 2005 US$) of Comoros and Value added (constant 2005 US$) of Madagascar?
Offer a very short reply. -7.32e+08. In the year 2010, what is the difference between the Value added (constant 2005 US$) of Comoros and Value added (constant 2005 US$) of Timor-Leste?
Provide a succinct answer. -8.62e+07. In the year 2010, what is the difference between the Value added (constant 2005 US$) of Honduras and Value added (constant 2005 US$) of Madagascar?
Offer a terse response. 2.05e+09. In the year 2010, what is the difference between the Value added (constant 2005 US$) of Honduras and Value added (constant 2005 US$) of Timor-Leste?
Your answer should be compact. 2.69e+09. In the year 2010, what is the difference between the Value added (constant 2005 US$) in Madagascar and Value added (constant 2005 US$) in Timor-Leste?
Make the answer very short. 6.46e+08. What is the ratio of the Value added (constant 2005 US$) in Comoros in 2004 to that in 2005?
Give a very brief answer. 0.98. What is the ratio of the Value added (constant 2005 US$) in Honduras in 2004 to that in 2005?
Keep it short and to the point. 0.93. What is the ratio of the Value added (constant 2005 US$) of Madagascar in 2004 to that in 2005?
Keep it short and to the point. 0.97. What is the ratio of the Value added (constant 2005 US$) of Timor-Leste in 2004 to that in 2005?
Offer a terse response. 1.05. What is the ratio of the Value added (constant 2005 US$) of Comoros in 2004 to that in 2006?
Provide a short and direct response. 0.95. What is the ratio of the Value added (constant 2005 US$) of Honduras in 2004 to that in 2006?
Give a very brief answer. 0.87. What is the ratio of the Value added (constant 2005 US$) in Madagascar in 2004 to that in 2006?
Your response must be concise. 0.94. What is the ratio of the Value added (constant 2005 US$) of Timor-Leste in 2004 to that in 2006?
Offer a very short reply. 1.59. What is the ratio of the Value added (constant 2005 US$) of Comoros in 2004 to that in 2007?
Provide a short and direct response. 0.99. What is the ratio of the Value added (constant 2005 US$) in Honduras in 2004 to that in 2007?
Offer a very short reply. 0.82. What is the ratio of the Value added (constant 2005 US$) of Madagascar in 2004 to that in 2007?
Offer a terse response. 0.85. What is the ratio of the Value added (constant 2005 US$) of Timor-Leste in 2004 to that in 2007?
Give a very brief answer. 1.07. What is the ratio of the Value added (constant 2005 US$) in Comoros in 2004 to that in 2008?
Offer a very short reply. 0.95. What is the ratio of the Value added (constant 2005 US$) of Honduras in 2004 to that in 2008?
Make the answer very short. 0.79. What is the ratio of the Value added (constant 2005 US$) of Madagascar in 2004 to that in 2008?
Provide a succinct answer. 0.82. What is the ratio of the Value added (constant 2005 US$) in Timor-Leste in 2004 to that in 2008?
Provide a short and direct response. 0.53. What is the ratio of the Value added (constant 2005 US$) of Comoros in 2004 to that in 2009?
Keep it short and to the point. 0.93. What is the ratio of the Value added (constant 2005 US$) of Honduras in 2004 to that in 2009?
Your answer should be very brief. 0.86. What is the ratio of the Value added (constant 2005 US$) in Madagascar in 2004 to that in 2009?
Provide a succinct answer. 0.89. What is the ratio of the Value added (constant 2005 US$) in Timor-Leste in 2004 to that in 2009?
Offer a very short reply. 0.37. What is the ratio of the Value added (constant 2005 US$) in Comoros in 2004 to that in 2010?
Offer a very short reply. 0.83. What is the ratio of the Value added (constant 2005 US$) in Honduras in 2004 to that in 2010?
Your answer should be compact. 0.83. What is the ratio of the Value added (constant 2005 US$) of Madagascar in 2004 to that in 2010?
Your response must be concise. 0.89. What is the ratio of the Value added (constant 2005 US$) in Timor-Leste in 2004 to that in 2010?
Your answer should be very brief. 0.36. What is the ratio of the Value added (constant 2005 US$) of Comoros in 2005 to that in 2006?
Your response must be concise. 0.97. What is the ratio of the Value added (constant 2005 US$) of Honduras in 2005 to that in 2006?
Provide a succinct answer. 0.94. What is the ratio of the Value added (constant 2005 US$) in Madagascar in 2005 to that in 2006?
Keep it short and to the point. 0.97. What is the ratio of the Value added (constant 2005 US$) in Timor-Leste in 2005 to that in 2006?
Keep it short and to the point. 1.51. What is the ratio of the Value added (constant 2005 US$) of Comoros in 2005 to that in 2007?
Offer a terse response. 1.02. What is the ratio of the Value added (constant 2005 US$) in Honduras in 2005 to that in 2007?
Make the answer very short. 0.88. What is the ratio of the Value added (constant 2005 US$) of Madagascar in 2005 to that in 2007?
Your response must be concise. 0.88. What is the ratio of the Value added (constant 2005 US$) of Timor-Leste in 2005 to that in 2007?
Your answer should be very brief. 1.02. What is the ratio of the Value added (constant 2005 US$) of Comoros in 2005 to that in 2008?
Your answer should be very brief. 0.97. What is the ratio of the Value added (constant 2005 US$) in Honduras in 2005 to that in 2008?
Your answer should be very brief. 0.85. What is the ratio of the Value added (constant 2005 US$) of Madagascar in 2005 to that in 2008?
Ensure brevity in your answer.  0.85. What is the ratio of the Value added (constant 2005 US$) in Comoros in 2005 to that in 2009?
Ensure brevity in your answer.  0.95. What is the ratio of the Value added (constant 2005 US$) of Honduras in 2005 to that in 2009?
Your answer should be compact. 0.92. What is the ratio of the Value added (constant 2005 US$) of Madagascar in 2005 to that in 2009?
Keep it short and to the point. 0.92. What is the ratio of the Value added (constant 2005 US$) of Timor-Leste in 2005 to that in 2009?
Offer a very short reply. 0.35. What is the ratio of the Value added (constant 2005 US$) of Comoros in 2005 to that in 2010?
Offer a very short reply. 0.85. What is the ratio of the Value added (constant 2005 US$) of Honduras in 2005 to that in 2010?
Your response must be concise. 0.9. What is the ratio of the Value added (constant 2005 US$) of Madagascar in 2005 to that in 2010?
Offer a terse response. 0.92. What is the ratio of the Value added (constant 2005 US$) of Timor-Leste in 2005 to that in 2010?
Your answer should be very brief. 0.34. What is the ratio of the Value added (constant 2005 US$) in Comoros in 2006 to that in 2007?
Provide a short and direct response. 1.05. What is the ratio of the Value added (constant 2005 US$) in Honduras in 2006 to that in 2007?
Provide a short and direct response. 0.94. What is the ratio of the Value added (constant 2005 US$) in Madagascar in 2006 to that in 2007?
Your answer should be very brief. 0.91. What is the ratio of the Value added (constant 2005 US$) of Timor-Leste in 2006 to that in 2007?
Your answer should be compact. 0.67. What is the ratio of the Value added (constant 2005 US$) in Honduras in 2006 to that in 2008?
Give a very brief answer. 0.91. What is the ratio of the Value added (constant 2005 US$) of Madagascar in 2006 to that in 2008?
Offer a very short reply. 0.88. What is the ratio of the Value added (constant 2005 US$) of Timor-Leste in 2006 to that in 2008?
Your answer should be compact. 0.33. What is the ratio of the Value added (constant 2005 US$) in Comoros in 2006 to that in 2009?
Offer a very short reply. 0.98. What is the ratio of the Value added (constant 2005 US$) of Honduras in 2006 to that in 2009?
Make the answer very short. 0.98. What is the ratio of the Value added (constant 2005 US$) of Madagascar in 2006 to that in 2009?
Provide a short and direct response. 0.95. What is the ratio of the Value added (constant 2005 US$) of Timor-Leste in 2006 to that in 2009?
Keep it short and to the point. 0.23. What is the ratio of the Value added (constant 2005 US$) in Comoros in 2006 to that in 2010?
Make the answer very short. 0.87. What is the ratio of the Value added (constant 2005 US$) in Honduras in 2006 to that in 2010?
Offer a very short reply. 0.95. What is the ratio of the Value added (constant 2005 US$) in Madagascar in 2006 to that in 2010?
Your answer should be very brief. 0.95. What is the ratio of the Value added (constant 2005 US$) of Timor-Leste in 2006 to that in 2010?
Offer a very short reply. 0.22. What is the ratio of the Value added (constant 2005 US$) in Comoros in 2007 to that in 2008?
Offer a terse response. 0.96. What is the ratio of the Value added (constant 2005 US$) of Honduras in 2007 to that in 2008?
Provide a short and direct response. 0.96. What is the ratio of the Value added (constant 2005 US$) of Madagascar in 2007 to that in 2008?
Make the answer very short. 0.97. What is the ratio of the Value added (constant 2005 US$) in Timor-Leste in 2007 to that in 2008?
Keep it short and to the point. 0.49. What is the ratio of the Value added (constant 2005 US$) in Comoros in 2007 to that in 2009?
Keep it short and to the point. 0.94. What is the ratio of the Value added (constant 2005 US$) of Honduras in 2007 to that in 2009?
Your answer should be very brief. 1.04. What is the ratio of the Value added (constant 2005 US$) in Madagascar in 2007 to that in 2009?
Offer a terse response. 1.05. What is the ratio of the Value added (constant 2005 US$) in Timor-Leste in 2007 to that in 2009?
Make the answer very short. 0.35. What is the ratio of the Value added (constant 2005 US$) of Comoros in 2007 to that in 2010?
Offer a terse response. 0.83. What is the ratio of the Value added (constant 2005 US$) in Honduras in 2007 to that in 2010?
Your answer should be very brief. 1.01. What is the ratio of the Value added (constant 2005 US$) of Madagascar in 2007 to that in 2010?
Provide a short and direct response. 1.04. What is the ratio of the Value added (constant 2005 US$) in Timor-Leste in 2007 to that in 2010?
Keep it short and to the point. 0.33. What is the ratio of the Value added (constant 2005 US$) of Comoros in 2008 to that in 2009?
Provide a succinct answer. 0.98. What is the ratio of the Value added (constant 2005 US$) in Madagascar in 2008 to that in 2009?
Keep it short and to the point. 1.08. What is the ratio of the Value added (constant 2005 US$) in Timor-Leste in 2008 to that in 2009?
Ensure brevity in your answer.  0.71. What is the ratio of the Value added (constant 2005 US$) of Comoros in 2008 to that in 2010?
Provide a short and direct response. 0.87. What is the ratio of the Value added (constant 2005 US$) of Honduras in 2008 to that in 2010?
Offer a terse response. 1.05. What is the ratio of the Value added (constant 2005 US$) of Madagascar in 2008 to that in 2010?
Offer a very short reply. 1.08. What is the ratio of the Value added (constant 2005 US$) in Timor-Leste in 2008 to that in 2010?
Ensure brevity in your answer.  0.67. What is the ratio of the Value added (constant 2005 US$) of Comoros in 2009 to that in 2010?
Give a very brief answer. 0.89. What is the ratio of the Value added (constant 2005 US$) in Honduras in 2009 to that in 2010?
Ensure brevity in your answer.  0.97. What is the ratio of the Value added (constant 2005 US$) of Madagascar in 2009 to that in 2010?
Offer a very short reply. 1. What is the ratio of the Value added (constant 2005 US$) of Timor-Leste in 2009 to that in 2010?
Make the answer very short. 0.95. What is the difference between the highest and the second highest Value added (constant 2005 US$) of Comoros?
Offer a terse response. 5.99e+06. What is the difference between the highest and the second highest Value added (constant 2005 US$) of Honduras?
Provide a short and direct response. 1.10e+08. What is the difference between the highest and the second highest Value added (constant 2005 US$) of Madagascar?
Provide a succinct answer. 2.93e+07. What is the difference between the highest and the second highest Value added (constant 2005 US$) of Timor-Leste?
Your answer should be compact. 6.71e+06. What is the difference between the highest and the lowest Value added (constant 2005 US$) in Comoros?
Provide a short and direct response. 9.29e+06. What is the difference between the highest and the lowest Value added (constant 2005 US$) in Honduras?
Offer a very short reply. 6.21e+08. What is the difference between the highest and the lowest Value added (constant 2005 US$) of Madagascar?
Offer a very short reply. 1.49e+08. What is the difference between the highest and the lowest Value added (constant 2005 US$) in Timor-Leste?
Your answer should be compact. 1.08e+08. 